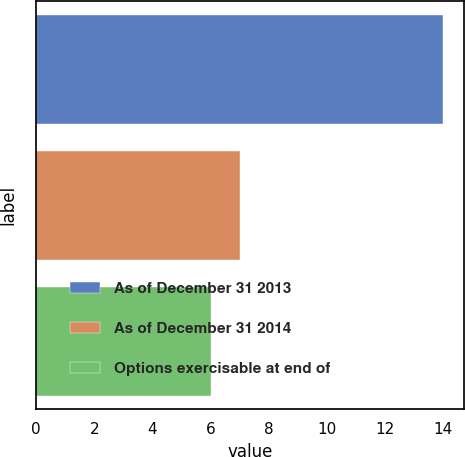Convert chart to OTSL. <chart><loc_0><loc_0><loc_500><loc_500><bar_chart><fcel>As of December 31 2013<fcel>As of December 31 2014<fcel>Options exercisable at end of<nl><fcel>14<fcel>7<fcel>6<nl></chart> 